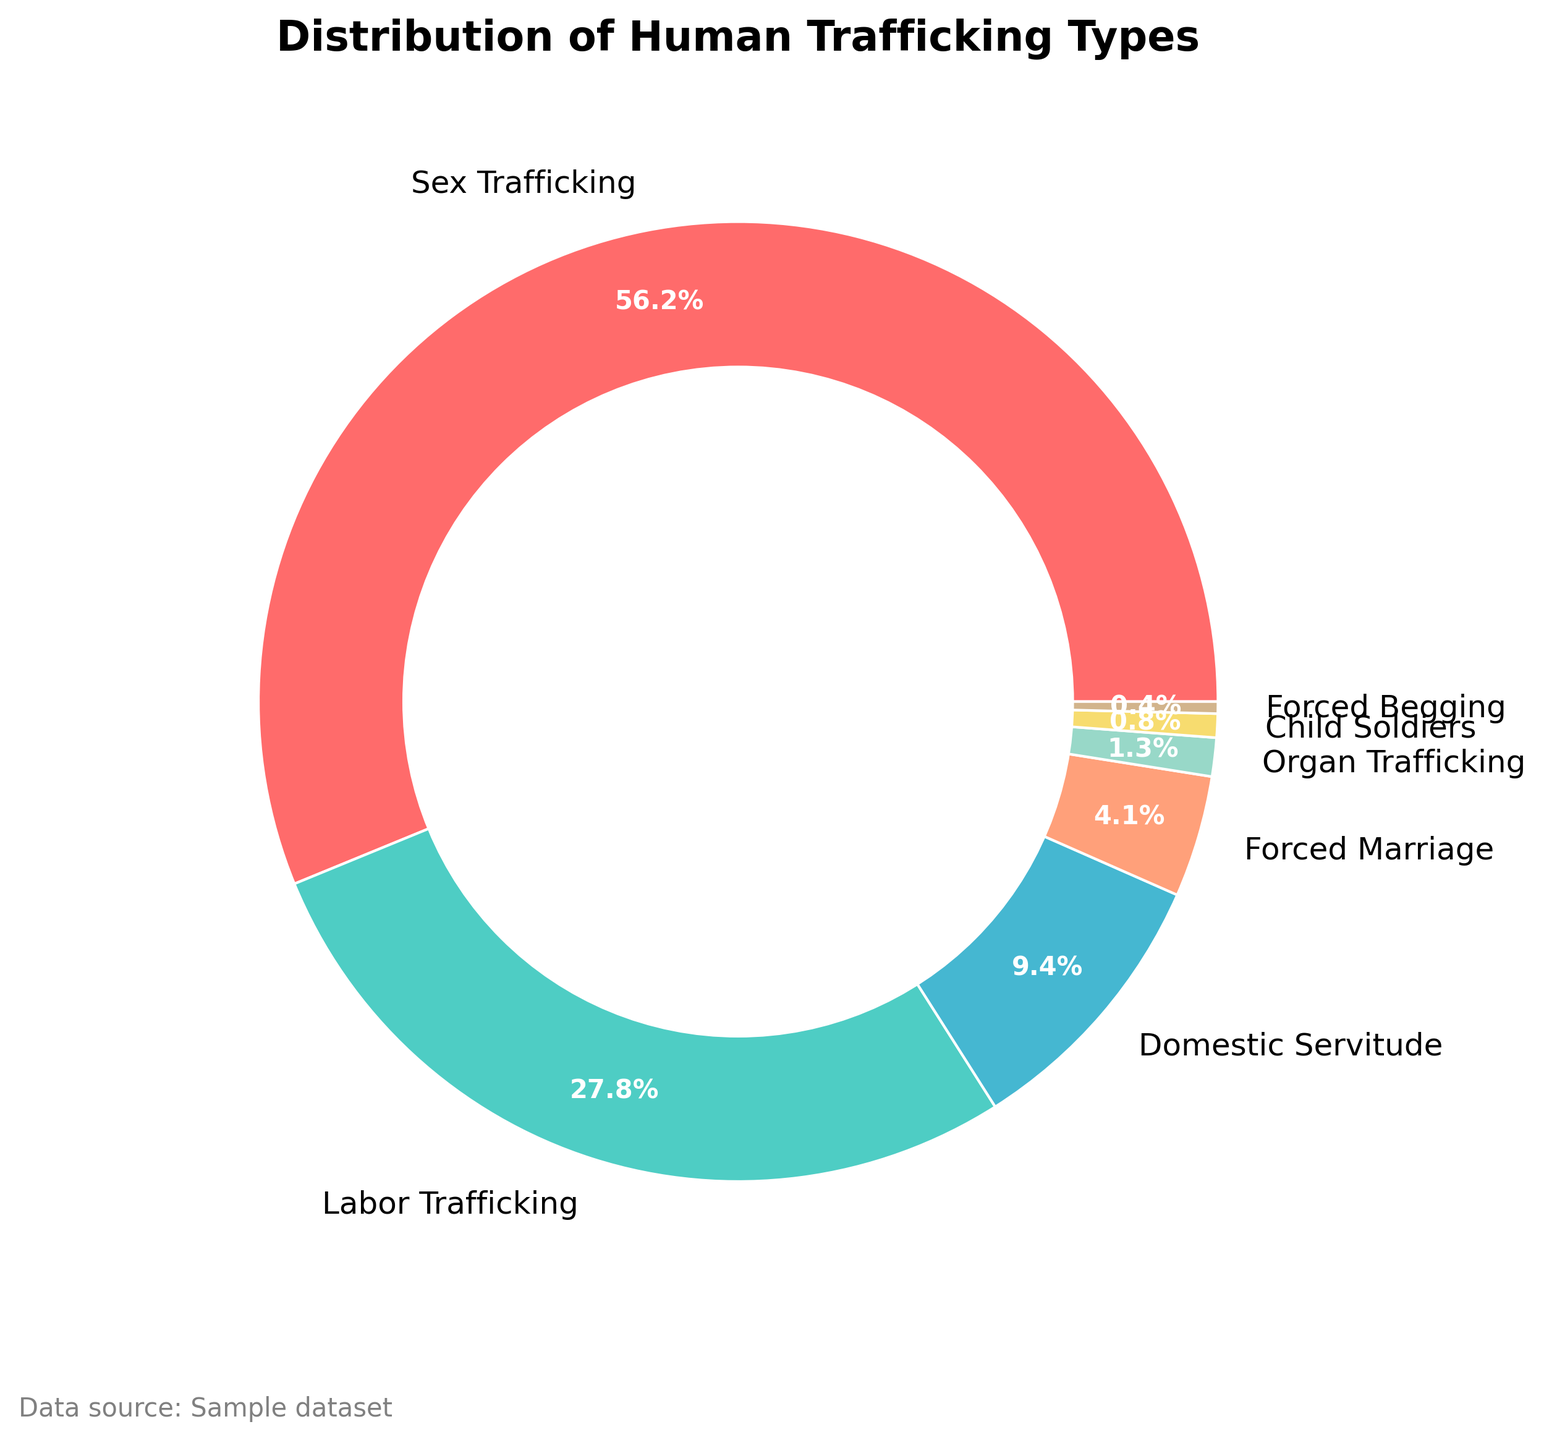What percentage of human trafficking is accounted for by labor-related activities (combining Labor Trafficking and Domestic Servitude)? First, identify the percentages for Labor Trafficking (27.8%) and Domestic Servitude (9.4%) from the figure. Then, sum these percentages: 27.8 + 9.4 = 37.2%
Answer: 37.2% What is the smallest category represented in the pie chart? Look at the different segments of the pie chart and identify the smallest one, which is Forced Begging at 0.4%.
Answer: Forced Begging How many more percentage points does Sex Trafficking have than Labor Trafficking? Refer to the pie chart: Sex Trafficking is 56.2%, and Labor Trafficking is 27.8%. Subtract Labor Trafficking from Sex Trafficking: 56.2 - 27.8 = 28.4 percentage points.
Answer: 28.4 percentage points Which categories together make up less than 10% of the total distribution? Identify the categories with percentages less than 10% (Forced Marriage, Organ Trafficking, Child Soldiers, Forced Begging) and check their sums individually: All except Domestic Servitude fall in this category.
Answer: Forced Marriage, Organ Trafficking, Child Soldiers, Forced Begging What is the difference in percentage between the largest and smallest categories? The largest category is Sex Trafficking at 56.2%, and the smallest is Forced Begging at 0.4%. Subtract the smallest from the largest: 56.2 - 0.4 = 55.8%.
Answer: 55.8% What color represents Organ Trafficking? Identify the segment named "Organ Trafficking" and check its color, which is a light green shade.
Answer: Light green Which category accounts for just over 4% of the distribution? Refer to the figure for the category that is more than 4%, which is Forced Marriage at 4.1%.
Answer: Forced Marriage Out of Domestic Servitude and Forced Marriage, which has a larger percentage and by how much? Compare Domestic Servitude (9.4%) and Forced Marriage (4.1%). Subtract the smaller percentage from the larger one: 9.4 - 4.1 = 5.3%.
Answer: Domestic Servitude by 5.3% Are the categories "Organ Trafficking" and "Child Soldiers" combined less than 2% of the total? Check the percentages for both: Organ Trafficking is 1.3%, and Child Soldiers is 0.8%. Summing these gives: 1.3 + 0.8 = 2.1%, which is not less than 2%.
Answer: No What categories together equal more than 50% of the total distribution? Identify categories with significant percentages: starting with Sex Trafficking (56.2%), which alone accounts for more than 50%. So, no need to sum other categories.
Answer: Sex Trafficking 